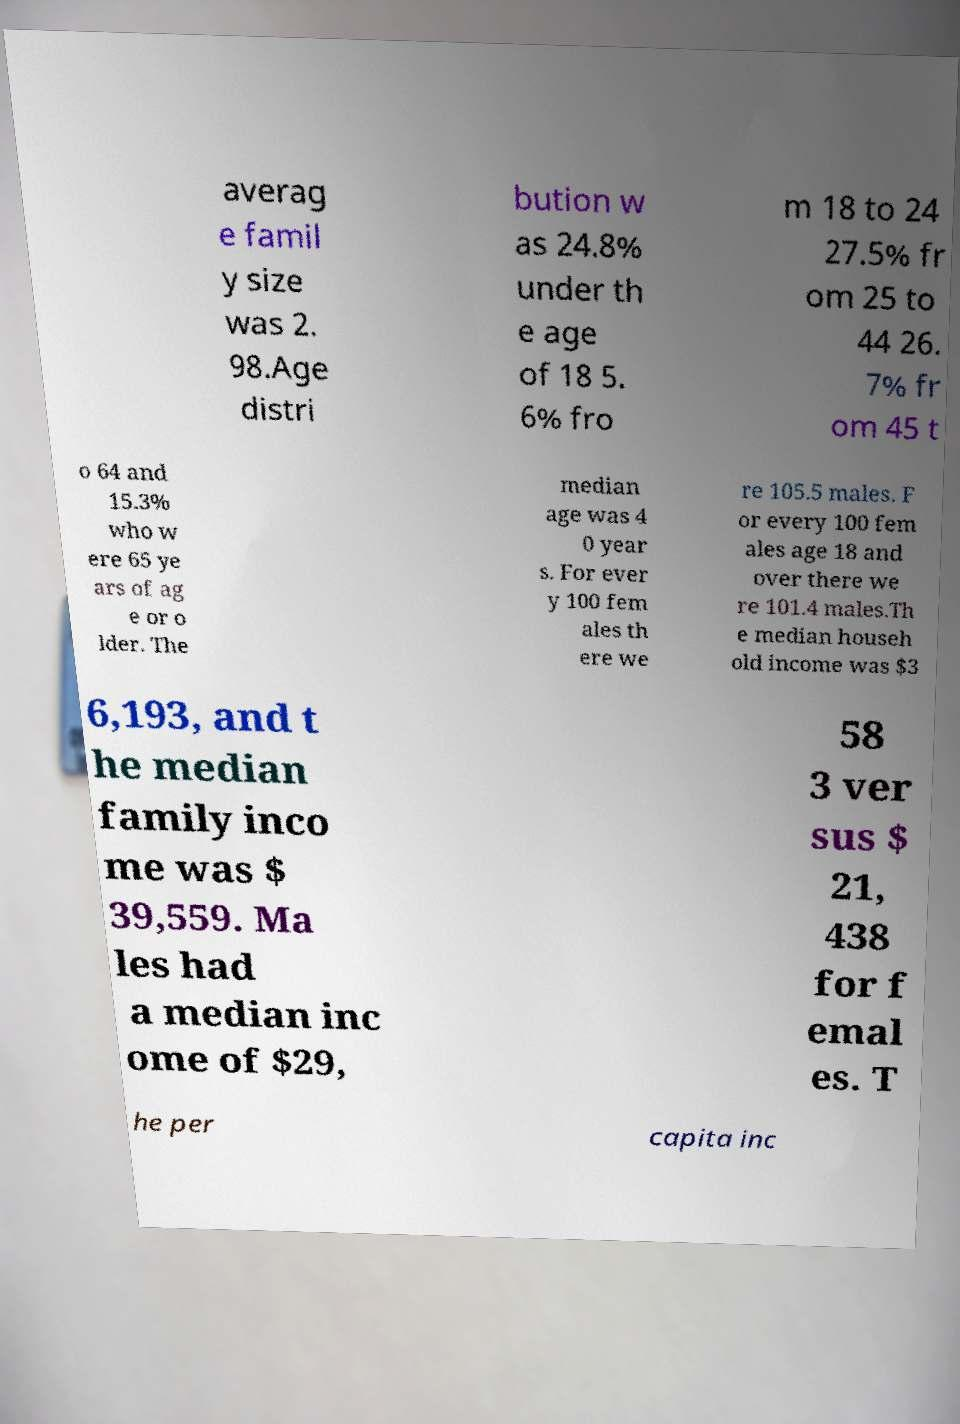Can you read and provide the text displayed in the image?This photo seems to have some interesting text. Can you extract and type it out for me? averag e famil y size was 2. 98.Age distri bution w as 24.8% under th e age of 18 5. 6% fro m 18 to 24 27.5% fr om 25 to 44 26. 7% fr om 45 t o 64 and 15.3% who w ere 65 ye ars of ag e or o lder. The median age was 4 0 year s. For ever y 100 fem ales th ere we re 105.5 males. F or every 100 fem ales age 18 and over there we re 101.4 males.Th e median househ old income was $3 6,193, and t he median family inco me was $ 39,559. Ma les had a median inc ome of $29, 58 3 ver sus $ 21, 438 for f emal es. T he per capita inc 